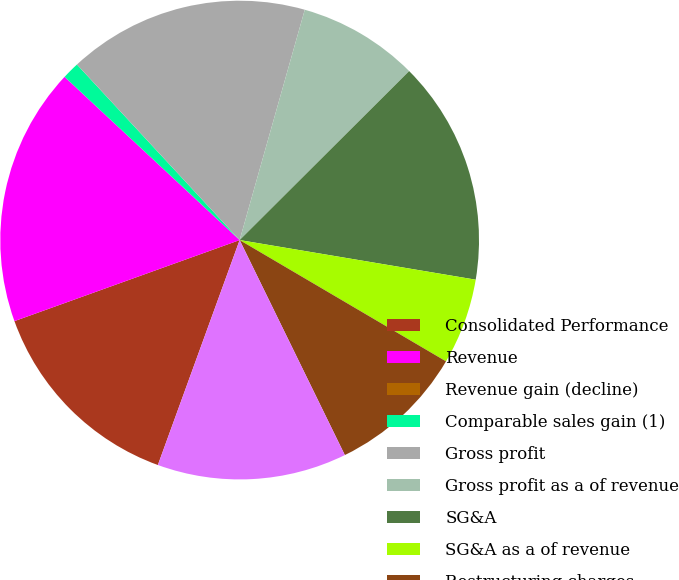Convert chart. <chart><loc_0><loc_0><loc_500><loc_500><pie_chart><fcel>Consolidated Performance<fcel>Revenue<fcel>Revenue gain (decline)<fcel>Comparable sales gain (1)<fcel>Gross profit<fcel>Gross profit as a of revenue<fcel>SG&A<fcel>SG&A as a of revenue<fcel>Restructuring charges<fcel>Operating income<nl><fcel>13.95%<fcel>17.44%<fcel>0.0%<fcel>1.16%<fcel>16.28%<fcel>8.14%<fcel>15.12%<fcel>5.81%<fcel>9.3%<fcel>12.79%<nl></chart> 